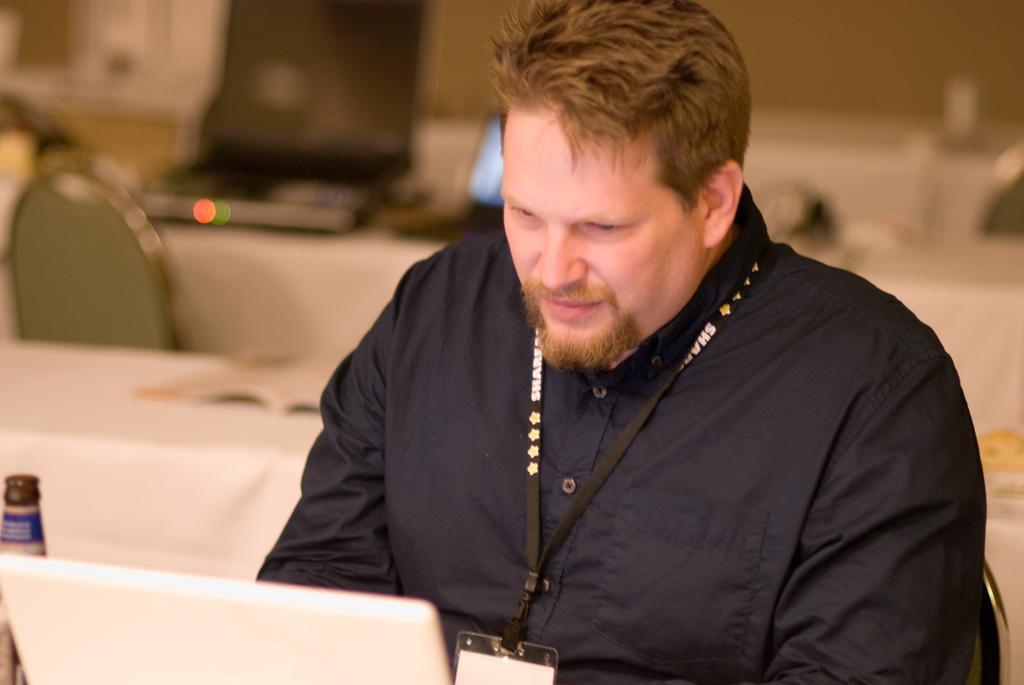In one or two sentences, can you explain what this image depicts? In this picture we can see a man, he is seated on the chair, in front of him we can find a laptop and a bottle, in the background we can see few more tables, chairs and laptops. 